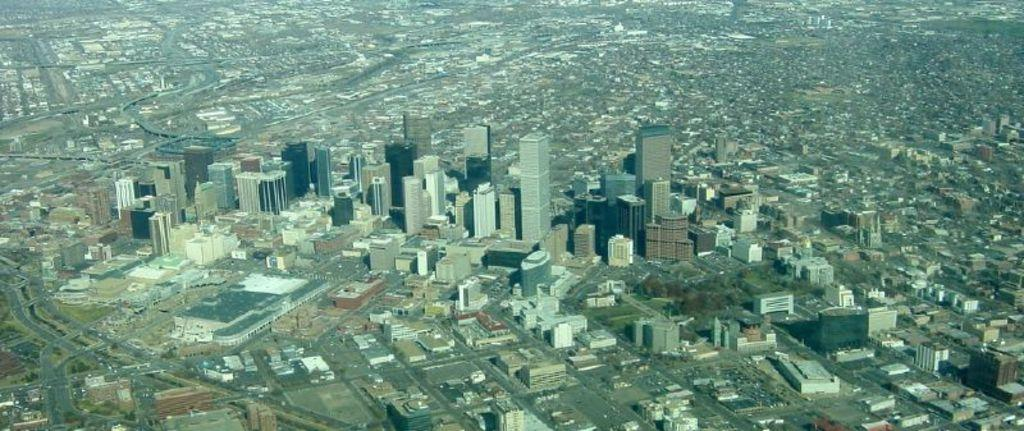What type of structures can be seen in the image? There are many buildings in the image. What type of vegetation is present in the image? There are trees in the image. Is there a boy playing with a toy car in the image? There is no boy or toy car present in the image. The image only contains buildings and trees. 